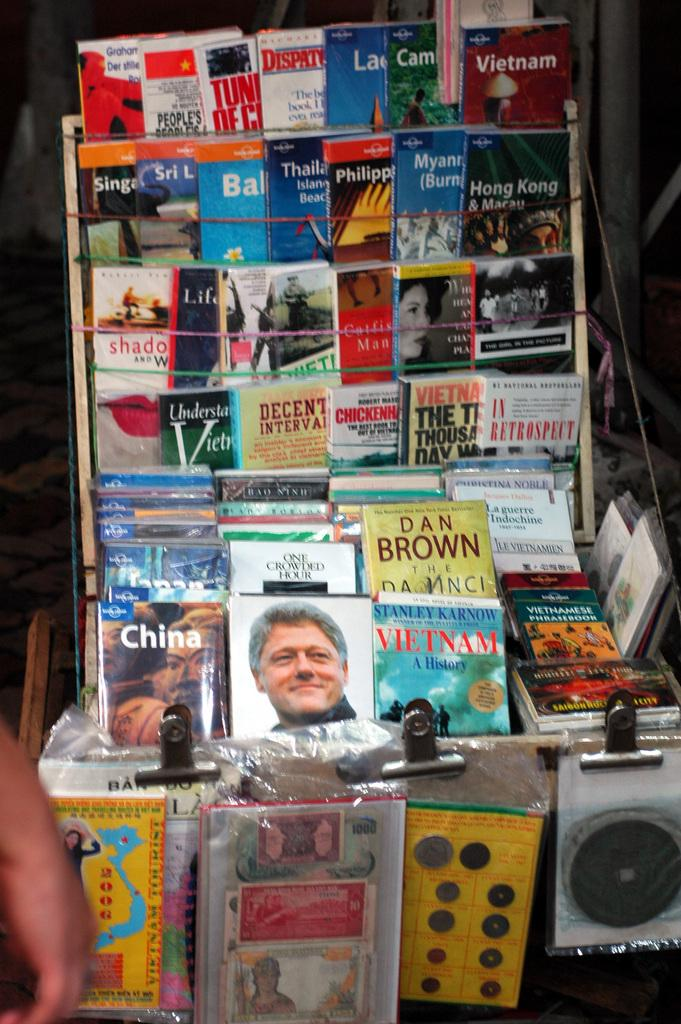What part of a person is visible in the image? There is a person's hand in the image. What type of objects can be seen in the image? There are books and clips in the image. What might be holding the books and clips together? There are other items on an object in the image that could be holding the books and clips together. Can you describe the background of the image? The background of the image is blurred. What type of dirt can be seen on the person's hand in the image? There is no dirt visible on the person's hand in the image. What sound can be heard coming from the books in the image? There is no sound present in the image, as it is a still photograph. 